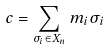<formula> <loc_0><loc_0><loc_500><loc_500>c = \sum _ { \sigma _ { i } \in X _ { n } } m _ { i } \sigma _ { i }</formula> 